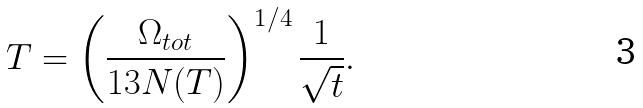<formula> <loc_0><loc_0><loc_500><loc_500>T = \left ( \frac { \Omega _ { t o t } } { 1 3 N ( T ) } \right ) ^ { 1 / 4 } \frac { 1 } { \sqrt { t } } .</formula> 